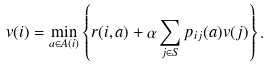Convert formula to latex. <formula><loc_0><loc_0><loc_500><loc_500>v ( i ) = \min _ { a \in A ( i ) } \left \{ r ( i , a ) + \alpha \sum _ { j \in S } p _ { i j } ( a ) v ( j ) \right \} .</formula> 